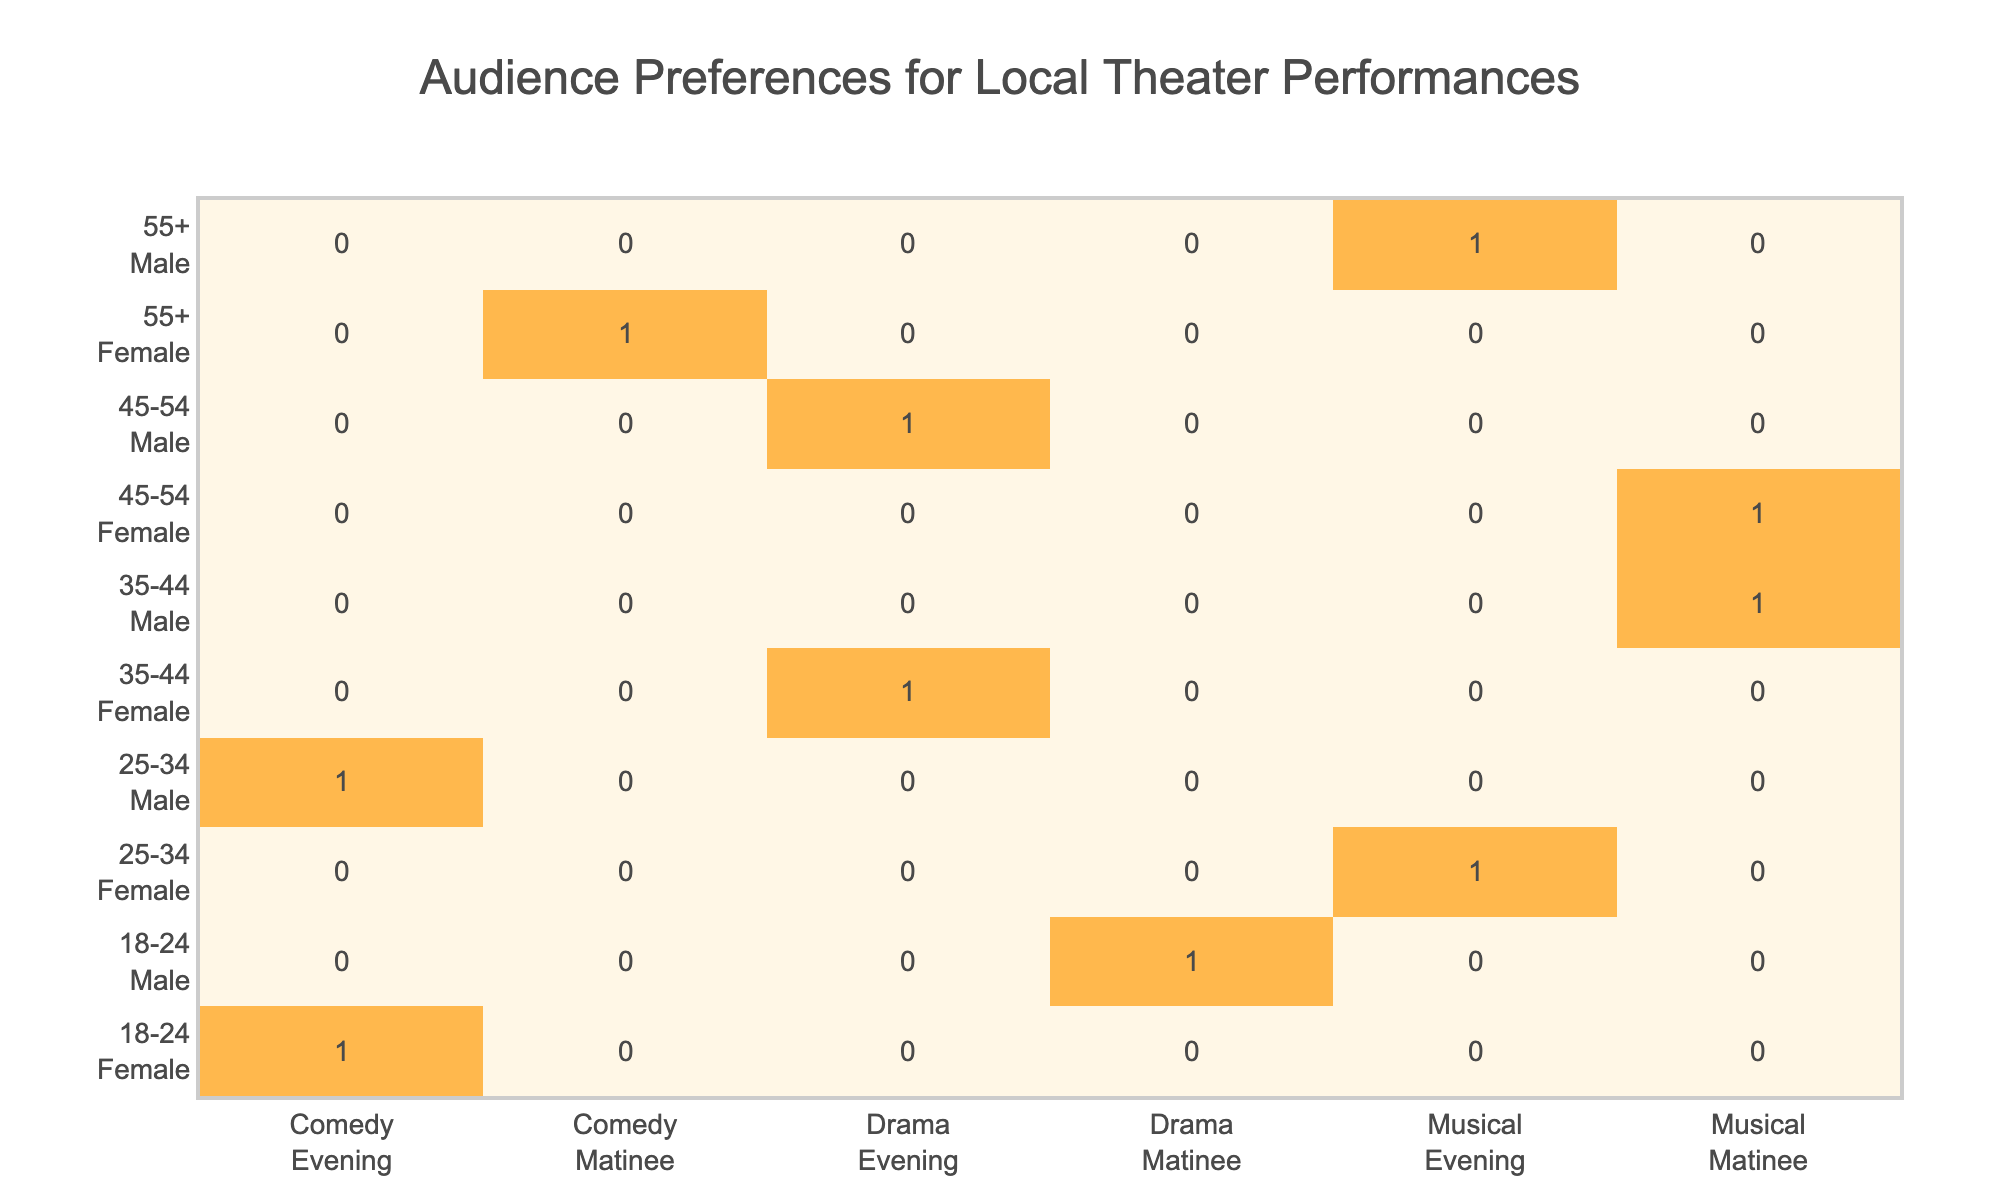What is the most popular genre preference among females aged 18-24? Looking at the table, the only entry for females in the 18-24 age group is for Comedy with an Evening time slot. Hence, the most popular genre for this group is Comedy.
Answer: Comedy Which age group has the highest number of male preferences for the Musical genre in the Evening time slot? The 55+ age group has a male preference for the Musical genre in the Evening time slot based on the table. The only other male preference for Musical is in the 35-44 age group for the Matinee time slot. Therefore, the 55+ age group is the only one that meets the criteria.
Answer: 55+ Is there a preference for Matinee performances among males? Yes, in the table, there are two preferences for males enjoying the Matinee time slot - Drama (18-24) and Musical (35-44).
Answer: Yes How many total preferences are there for the Comedy genre across all demographics? The table shows that there are 3 preferences for Comedy: one female in the 18-24 age group for Evening, one female in the 55+ age group for Matinee, and one male in the 25-34 age group for Evening. Summing these gives us 3 preferences total.
Answer: 3 Among the 45-54 age group, is there a preference for Musical performances in any time slot? Yes, the table shows that there is one preference for Musical among females (Matinee) in the 45-54 age group, indicating a confirmed interest in that genre by that demographic.
Answer: Yes What is the difference in the number of Evening genre preferences between males and females aged 35-44? For Females aged 35-44, there is 1 preference for Drama (Evening) and for Males aged 35-44, there is 1 preference for Musical (Matinee). Males have 0 for Evening, which gives a difference of 1 for females.
Answer: 1 Which genre do females in the 25-34 age group prefer, and how does this compare to males in the same age group? Females in the 25-34 age group prefer Musical, while males in the same age group prefer Comedy. Thus, the comparison shows that females lean towards Musical, whereas males prefer Comedy.
Answer: Musical for females, Comedy for males Are there any preferences for Drama performances in the Evening time slot? Yes, there are two preferences for Drama in the Evening time slot from females in the 35-44 age group and males in the 45-54 age group, confirming interest in Drama during that time.
Answer: Yes 